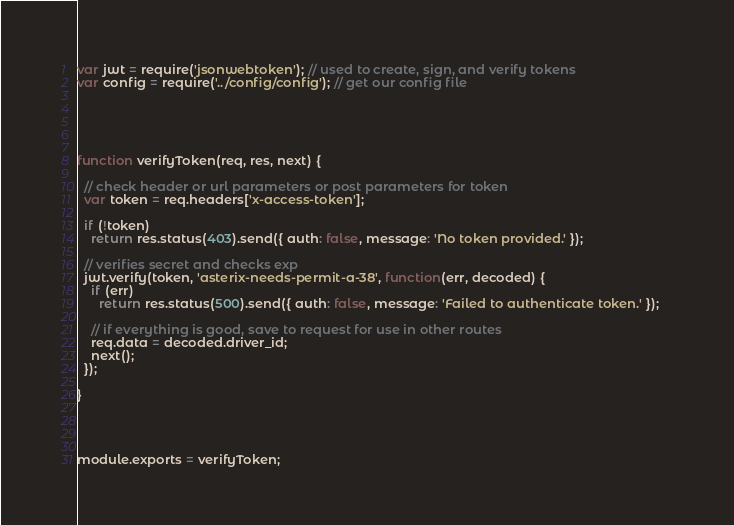Convert code to text. <code><loc_0><loc_0><loc_500><loc_500><_JavaScript_>var jwt = require('jsonwebtoken'); // used to create, sign, and verify tokens
var config = require('../config/config'); // get our config file





function verifyToken(req, res, next) {

  // check header or url parameters or post parameters for token
  var token = req.headers['x-access-token'];

  if (!token) 
    return res.status(403).send({ auth: false, message: 'No token provided.' });

  // verifies secret and checks exp
  jwt.verify(token, 'asterix-needs-permit-a-38', function(err, decoded) {      
    if (err) 
      return res.status(500).send({ auth: false, message: 'Failed to authenticate token.' });    

    // if everything is good, save to request for use in other routes
    req.data = decoded.driver_id;
    next();
  });

}




module.exports = verifyToken;</code> 